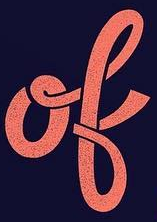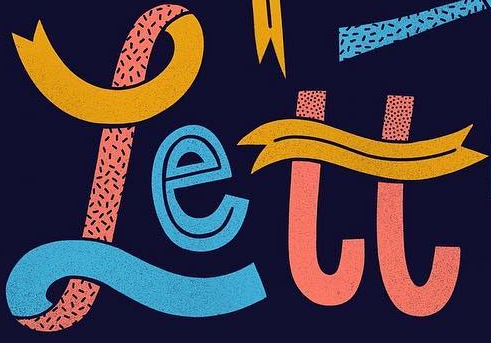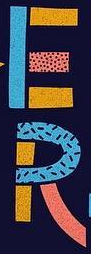What words can you see in these images in sequence, separated by a semicolon? ok; rett; ER 